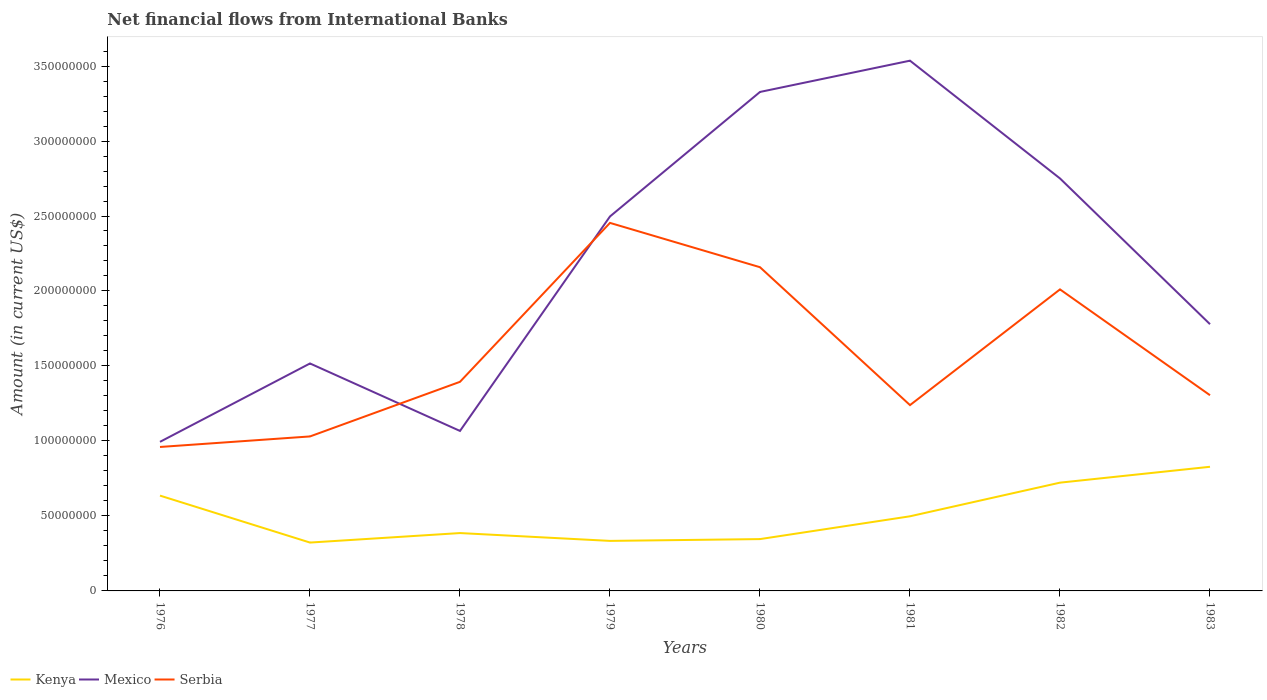Is the number of lines equal to the number of legend labels?
Offer a very short reply. Yes. Across all years, what is the maximum net financial aid flows in Mexico?
Make the answer very short. 9.94e+07. In which year was the net financial aid flows in Serbia maximum?
Keep it short and to the point. 1976. What is the total net financial aid flows in Kenya in the graph?
Provide a short and direct response. -1.11e+06. What is the difference between the highest and the second highest net financial aid flows in Serbia?
Provide a succinct answer. 1.49e+08. How many lines are there?
Your answer should be very brief. 3. How many years are there in the graph?
Ensure brevity in your answer.  8. Are the values on the major ticks of Y-axis written in scientific E-notation?
Your response must be concise. No. Does the graph contain grids?
Ensure brevity in your answer.  No. How many legend labels are there?
Your response must be concise. 3. How are the legend labels stacked?
Your response must be concise. Horizontal. What is the title of the graph?
Offer a terse response. Net financial flows from International Banks. Does "Colombia" appear as one of the legend labels in the graph?
Keep it short and to the point. No. What is the label or title of the X-axis?
Provide a succinct answer. Years. What is the label or title of the Y-axis?
Ensure brevity in your answer.  Amount (in current US$). What is the Amount (in current US$) of Kenya in 1976?
Your answer should be compact. 6.36e+07. What is the Amount (in current US$) of Mexico in 1976?
Offer a very short reply. 9.94e+07. What is the Amount (in current US$) in Serbia in 1976?
Offer a very short reply. 9.60e+07. What is the Amount (in current US$) in Kenya in 1977?
Keep it short and to the point. 3.22e+07. What is the Amount (in current US$) in Mexico in 1977?
Provide a short and direct response. 1.52e+08. What is the Amount (in current US$) in Serbia in 1977?
Your answer should be very brief. 1.03e+08. What is the Amount (in current US$) in Kenya in 1978?
Your answer should be compact. 3.86e+07. What is the Amount (in current US$) of Mexico in 1978?
Provide a succinct answer. 1.07e+08. What is the Amount (in current US$) of Serbia in 1978?
Offer a terse response. 1.39e+08. What is the Amount (in current US$) in Kenya in 1979?
Offer a terse response. 3.34e+07. What is the Amount (in current US$) of Mexico in 1979?
Keep it short and to the point. 2.50e+08. What is the Amount (in current US$) of Serbia in 1979?
Make the answer very short. 2.45e+08. What is the Amount (in current US$) of Kenya in 1980?
Your response must be concise. 3.46e+07. What is the Amount (in current US$) in Mexico in 1980?
Offer a very short reply. 3.33e+08. What is the Amount (in current US$) in Serbia in 1980?
Keep it short and to the point. 2.16e+08. What is the Amount (in current US$) of Kenya in 1981?
Provide a short and direct response. 4.98e+07. What is the Amount (in current US$) in Mexico in 1981?
Offer a very short reply. 3.54e+08. What is the Amount (in current US$) of Serbia in 1981?
Ensure brevity in your answer.  1.24e+08. What is the Amount (in current US$) in Kenya in 1982?
Your answer should be compact. 7.22e+07. What is the Amount (in current US$) of Mexico in 1982?
Your answer should be compact. 2.75e+08. What is the Amount (in current US$) of Serbia in 1982?
Your answer should be compact. 2.01e+08. What is the Amount (in current US$) in Kenya in 1983?
Offer a very short reply. 8.28e+07. What is the Amount (in current US$) in Mexico in 1983?
Keep it short and to the point. 1.78e+08. What is the Amount (in current US$) of Serbia in 1983?
Provide a succinct answer. 1.30e+08. Across all years, what is the maximum Amount (in current US$) of Kenya?
Provide a short and direct response. 8.28e+07. Across all years, what is the maximum Amount (in current US$) of Mexico?
Provide a succinct answer. 3.54e+08. Across all years, what is the maximum Amount (in current US$) of Serbia?
Give a very brief answer. 2.45e+08. Across all years, what is the minimum Amount (in current US$) of Kenya?
Your answer should be compact. 3.22e+07. Across all years, what is the minimum Amount (in current US$) in Mexico?
Your response must be concise. 9.94e+07. Across all years, what is the minimum Amount (in current US$) in Serbia?
Make the answer very short. 9.60e+07. What is the total Amount (in current US$) in Kenya in the graph?
Your answer should be compact. 4.07e+08. What is the total Amount (in current US$) in Mexico in the graph?
Ensure brevity in your answer.  1.75e+09. What is the total Amount (in current US$) in Serbia in the graph?
Give a very brief answer. 1.26e+09. What is the difference between the Amount (in current US$) in Kenya in 1976 and that in 1977?
Offer a very short reply. 3.13e+07. What is the difference between the Amount (in current US$) of Mexico in 1976 and that in 1977?
Your answer should be very brief. -5.23e+07. What is the difference between the Amount (in current US$) of Serbia in 1976 and that in 1977?
Your answer should be very brief. -7.02e+06. What is the difference between the Amount (in current US$) in Kenya in 1976 and that in 1978?
Give a very brief answer. 2.50e+07. What is the difference between the Amount (in current US$) in Mexico in 1976 and that in 1978?
Ensure brevity in your answer.  -7.27e+06. What is the difference between the Amount (in current US$) of Serbia in 1976 and that in 1978?
Your answer should be very brief. -4.34e+07. What is the difference between the Amount (in current US$) in Kenya in 1976 and that in 1979?
Your answer should be very brief. 3.02e+07. What is the difference between the Amount (in current US$) in Mexico in 1976 and that in 1979?
Offer a very short reply. -1.50e+08. What is the difference between the Amount (in current US$) in Serbia in 1976 and that in 1979?
Make the answer very short. -1.49e+08. What is the difference between the Amount (in current US$) of Kenya in 1976 and that in 1980?
Provide a short and direct response. 2.90e+07. What is the difference between the Amount (in current US$) in Mexico in 1976 and that in 1980?
Give a very brief answer. -2.33e+08. What is the difference between the Amount (in current US$) of Serbia in 1976 and that in 1980?
Provide a succinct answer. -1.20e+08. What is the difference between the Amount (in current US$) of Kenya in 1976 and that in 1981?
Your response must be concise. 1.38e+07. What is the difference between the Amount (in current US$) in Mexico in 1976 and that in 1981?
Offer a terse response. -2.54e+08. What is the difference between the Amount (in current US$) in Serbia in 1976 and that in 1981?
Provide a succinct answer. -2.79e+07. What is the difference between the Amount (in current US$) in Kenya in 1976 and that in 1982?
Provide a succinct answer. -8.65e+06. What is the difference between the Amount (in current US$) in Mexico in 1976 and that in 1982?
Give a very brief answer. -1.76e+08. What is the difference between the Amount (in current US$) of Serbia in 1976 and that in 1982?
Offer a very short reply. -1.05e+08. What is the difference between the Amount (in current US$) of Kenya in 1976 and that in 1983?
Provide a succinct answer. -1.92e+07. What is the difference between the Amount (in current US$) in Mexico in 1976 and that in 1983?
Ensure brevity in your answer.  -7.85e+07. What is the difference between the Amount (in current US$) of Serbia in 1976 and that in 1983?
Offer a terse response. -3.45e+07. What is the difference between the Amount (in current US$) of Kenya in 1977 and that in 1978?
Provide a succinct answer. -6.34e+06. What is the difference between the Amount (in current US$) of Mexico in 1977 and that in 1978?
Your response must be concise. 4.50e+07. What is the difference between the Amount (in current US$) in Serbia in 1977 and that in 1978?
Provide a succinct answer. -3.64e+07. What is the difference between the Amount (in current US$) of Kenya in 1977 and that in 1979?
Your response must be concise. -1.11e+06. What is the difference between the Amount (in current US$) of Mexico in 1977 and that in 1979?
Give a very brief answer. -9.80e+07. What is the difference between the Amount (in current US$) in Serbia in 1977 and that in 1979?
Your answer should be very brief. -1.42e+08. What is the difference between the Amount (in current US$) of Kenya in 1977 and that in 1980?
Provide a short and direct response. -2.32e+06. What is the difference between the Amount (in current US$) in Mexico in 1977 and that in 1980?
Make the answer very short. -1.81e+08. What is the difference between the Amount (in current US$) in Serbia in 1977 and that in 1980?
Ensure brevity in your answer.  -1.13e+08. What is the difference between the Amount (in current US$) in Kenya in 1977 and that in 1981?
Keep it short and to the point. -1.75e+07. What is the difference between the Amount (in current US$) of Mexico in 1977 and that in 1981?
Your response must be concise. -2.02e+08. What is the difference between the Amount (in current US$) in Serbia in 1977 and that in 1981?
Make the answer very short. -2.09e+07. What is the difference between the Amount (in current US$) in Kenya in 1977 and that in 1982?
Provide a short and direct response. -4.00e+07. What is the difference between the Amount (in current US$) in Mexico in 1977 and that in 1982?
Your response must be concise. -1.23e+08. What is the difference between the Amount (in current US$) in Serbia in 1977 and that in 1982?
Ensure brevity in your answer.  -9.80e+07. What is the difference between the Amount (in current US$) of Kenya in 1977 and that in 1983?
Give a very brief answer. -5.05e+07. What is the difference between the Amount (in current US$) of Mexico in 1977 and that in 1983?
Keep it short and to the point. -2.62e+07. What is the difference between the Amount (in current US$) in Serbia in 1977 and that in 1983?
Your answer should be compact. -2.75e+07. What is the difference between the Amount (in current US$) in Kenya in 1978 and that in 1979?
Your answer should be very brief. 5.22e+06. What is the difference between the Amount (in current US$) in Mexico in 1978 and that in 1979?
Keep it short and to the point. -1.43e+08. What is the difference between the Amount (in current US$) of Serbia in 1978 and that in 1979?
Offer a very short reply. -1.06e+08. What is the difference between the Amount (in current US$) of Kenya in 1978 and that in 1980?
Your answer should be very brief. 4.02e+06. What is the difference between the Amount (in current US$) in Mexico in 1978 and that in 1980?
Offer a terse response. -2.26e+08. What is the difference between the Amount (in current US$) in Serbia in 1978 and that in 1980?
Your answer should be very brief. -7.64e+07. What is the difference between the Amount (in current US$) of Kenya in 1978 and that in 1981?
Your answer should be very brief. -1.12e+07. What is the difference between the Amount (in current US$) of Mexico in 1978 and that in 1981?
Offer a very short reply. -2.47e+08. What is the difference between the Amount (in current US$) of Serbia in 1978 and that in 1981?
Make the answer very short. 1.55e+07. What is the difference between the Amount (in current US$) in Kenya in 1978 and that in 1982?
Give a very brief answer. -3.36e+07. What is the difference between the Amount (in current US$) of Mexico in 1978 and that in 1982?
Your answer should be very brief. -1.68e+08. What is the difference between the Amount (in current US$) of Serbia in 1978 and that in 1982?
Ensure brevity in your answer.  -6.16e+07. What is the difference between the Amount (in current US$) in Kenya in 1978 and that in 1983?
Your answer should be very brief. -4.42e+07. What is the difference between the Amount (in current US$) of Mexico in 1978 and that in 1983?
Ensure brevity in your answer.  -7.12e+07. What is the difference between the Amount (in current US$) in Serbia in 1978 and that in 1983?
Give a very brief answer. 8.94e+06. What is the difference between the Amount (in current US$) in Kenya in 1979 and that in 1980?
Keep it short and to the point. -1.20e+06. What is the difference between the Amount (in current US$) of Mexico in 1979 and that in 1980?
Offer a very short reply. -8.30e+07. What is the difference between the Amount (in current US$) of Serbia in 1979 and that in 1980?
Ensure brevity in your answer.  2.95e+07. What is the difference between the Amount (in current US$) of Kenya in 1979 and that in 1981?
Provide a succinct answer. -1.64e+07. What is the difference between the Amount (in current US$) of Mexico in 1979 and that in 1981?
Offer a very short reply. -1.04e+08. What is the difference between the Amount (in current US$) of Serbia in 1979 and that in 1981?
Provide a succinct answer. 1.22e+08. What is the difference between the Amount (in current US$) of Kenya in 1979 and that in 1982?
Your response must be concise. -3.88e+07. What is the difference between the Amount (in current US$) of Mexico in 1979 and that in 1982?
Give a very brief answer. -2.53e+07. What is the difference between the Amount (in current US$) in Serbia in 1979 and that in 1982?
Give a very brief answer. 4.43e+07. What is the difference between the Amount (in current US$) of Kenya in 1979 and that in 1983?
Make the answer very short. -4.94e+07. What is the difference between the Amount (in current US$) in Mexico in 1979 and that in 1983?
Provide a succinct answer. 7.18e+07. What is the difference between the Amount (in current US$) in Serbia in 1979 and that in 1983?
Give a very brief answer. 1.15e+08. What is the difference between the Amount (in current US$) of Kenya in 1980 and that in 1981?
Offer a terse response. -1.52e+07. What is the difference between the Amount (in current US$) of Mexico in 1980 and that in 1981?
Provide a succinct answer. -2.09e+07. What is the difference between the Amount (in current US$) in Serbia in 1980 and that in 1981?
Provide a short and direct response. 9.20e+07. What is the difference between the Amount (in current US$) of Kenya in 1980 and that in 1982?
Provide a succinct answer. -3.76e+07. What is the difference between the Amount (in current US$) of Mexico in 1980 and that in 1982?
Provide a succinct answer. 5.77e+07. What is the difference between the Amount (in current US$) of Serbia in 1980 and that in 1982?
Make the answer very short. 1.48e+07. What is the difference between the Amount (in current US$) in Kenya in 1980 and that in 1983?
Keep it short and to the point. -4.82e+07. What is the difference between the Amount (in current US$) in Mexico in 1980 and that in 1983?
Give a very brief answer. 1.55e+08. What is the difference between the Amount (in current US$) in Serbia in 1980 and that in 1983?
Give a very brief answer. 8.54e+07. What is the difference between the Amount (in current US$) of Kenya in 1981 and that in 1982?
Keep it short and to the point. -2.24e+07. What is the difference between the Amount (in current US$) in Mexico in 1981 and that in 1982?
Provide a short and direct response. 7.85e+07. What is the difference between the Amount (in current US$) of Serbia in 1981 and that in 1982?
Ensure brevity in your answer.  -7.72e+07. What is the difference between the Amount (in current US$) in Kenya in 1981 and that in 1983?
Make the answer very short. -3.30e+07. What is the difference between the Amount (in current US$) of Mexico in 1981 and that in 1983?
Your response must be concise. 1.76e+08. What is the difference between the Amount (in current US$) in Serbia in 1981 and that in 1983?
Offer a terse response. -6.60e+06. What is the difference between the Amount (in current US$) in Kenya in 1982 and that in 1983?
Ensure brevity in your answer.  -1.06e+07. What is the difference between the Amount (in current US$) in Mexico in 1982 and that in 1983?
Your response must be concise. 9.72e+07. What is the difference between the Amount (in current US$) of Serbia in 1982 and that in 1983?
Provide a short and direct response. 7.06e+07. What is the difference between the Amount (in current US$) in Kenya in 1976 and the Amount (in current US$) in Mexico in 1977?
Offer a very short reply. -8.81e+07. What is the difference between the Amount (in current US$) of Kenya in 1976 and the Amount (in current US$) of Serbia in 1977?
Your answer should be very brief. -3.95e+07. What is the difference between the Amount (in current US$) in Mexico in 1976 and the Amount (in current US$) in Serbia in 1977?
Offer a terse response. -3.61e+06. What is the difference between the Amount (in current US$) in Kenya in 1976 and the Amount (in current US$) in Mexico in 1978?
Offer a very short reply. -4.31e+07. What is the difference between the Amount (in current US$) of Kenya in 1976 and the Amount (in current US$) of Serbia in 1978?
Offer a very short reply. -7.59e+07. What is the difference between the Amount (in current US$) of Mexico in 1976 and the Amount (in current US$) of Serbia in 1978?
Offer a very short reply. -4.00e+07. What is the difference between the Amount (in current US$) of Kenya in 1976 and the Amount (in current US$) of Mexico in 1979?
Offer a very short reply. -1.86e+08. What is the difference between the Amount (in current US$) of Kenya in 1976 and the Amount (in current US$) of Serbia in 1979?
Keep it short and to the point. -1.82e+08. What is the difference between the Amount (in current US$) in Mexico in 1976 and the Amount (in current US$) in Serbia in 1979?
Offer a terse response. -1.46e+08. What is the difference between the Amount (in current US$) of Kenya in 1976 and the Amount (in current US$) of Mexico in 1980?
Your response must be concise. -2.69e+08. What is the difference between the Amount (in current US$) in Kenya in 1976 and the Amount (in current US$) in Serbia in 1980?
Your answer should be very brief. -1.52e+08. What is the difference between the Amount (in current US$) of Mexico in 1976 and the Amount (in current US$) of Serbia in 1980?
Your response must be concise. -1.16e+08. What is the difference between the Amount (in current US$) of Kenya in 1976 and the Amount (in current US$) of Mexico in 1981?
Your answer should be compact. -2.90e+08. What is the difference between the Amount (in current US$) of Kenya in 1976 and the Amount (in current US$) of Serbia in 1981?
Your answer should be very brief. -6.03e+07. What is the difference between the Amount (in current US$) in Mexico in 1976 and the Amount (in current US$) in Serbia in 1981?
Provide a succinct answer. -2.45e+07. What is the difference between the Amount (in current US$) in Kenya in 1976 and the Amount (in current US$) in Mexico in 1982?
Provide a succinct answer. -2.11e+08. What is the difference between the Amount (in current US$) in Kenya in 1976 and the Amount (in current US$) in Serbia in 1982?
Offer a terse response. -1.38e+08. What is the difference between the Amount (in current US$) of Mexico in 1976 and the Amount (in current US$) of Serbia in 1982?
Your answer should be compact. -1.02e+08. What is the difference between the Amount (in current US$) in Kenya in 1976 and the Amount (in current US$) in Mexico in 1983?
Offer a terse response. -1.14e+08. What is the difference between the Amount (in current US$) in Kenya in 1976 and the Amount (in current US$) in Serbia in 1983?
Give a very brief answer. -6.69e+07. What is the difference between the Amount (in current US$) of Mexico in 1976 and the Amount (in current US$) of Serbia in 1983?
Provide a short and direct response. -3.11e+07. What is the difference between the Amount (in current US$) in Kenya in 1977 and the Amount (in current US$) in Mexico in 1978?
Ensure brevity in your answer.  -7.44e+07. What is the difference between the Amount (in current US$) in Kenya in 1977 and the Amount (in current US$) in Serbia in 1978?
Your response must be concise. -1.07e+08. What is the difference between the Amount (in current US$) in Mexico in 1977 and the Amount (in current US$) in Serbia in 1978?
Give a very brief answer. 1.22e+07. What is the difference between the Amount (in current US$) in Kenya in 1977 and the Amount (in current US$) in Mexico in 1979?
Offer a terse response. -2.17e+08. What is the difference between the Amount (in current US$) of Kenya in 1977 and the Amount (in current US$) of Serbia in 1979?
Make the answer very short. -2.13e+08. What is the difference between the Amount (in current US$) of Mexico in 1977 and the Amount (in current US$) of Serbia in 1979?
Your answer should be compact. -9.37e+07. What is the difference between the Amount (in current US$) in Kenya in 1977 and the Amount (in current US$) in Mexico in 1980?
Provide a short and direct response. -3.00e+08. What is the difference between the Amount (in current US$) of Kenya in 1977 and the Amount (in current US$) of Serbia in 1980?
Your answer should be very brief. -1.84e+08. What is the difference between the Amount (in current US$) of Mexico in 1977 and the Amount (in current US$) of Serbia in 1980?
Ensure brevity in your answer.  -6.42e+07. What is the difference between the Amount (in current US$) of Kenya in 1977 and the Amount (in current US$) of Mexico in 1981?
Your answer should be very brief. -3.21e+08. What is the difference between the Amount (in current US$) of Kenya in 1977 and the Amount (in current US$) of Serbia in 1981?
Provide a succinct answer. -9.17e+07. What is the difference between the Amount (in current US$) in Mexico in 1977 and the Amount (in current US$) in Serbia in 1981?
Offer a very short reply. 2.78e+07. What is the difference between the Amount (in current US$) of Kenya in 1977 and the Amount (in current US$) of Mexico in 1982?
Give a very brief answer. -2.43e+08. What is the difference between the Amount (in current US$) of Kenya in 1977 and the Amount (in current US$) of Serbia in 1982?
Offer a terse response. -1.69e+08. What is the difference between the Amount (in current US$) in Mexico in 1977 and the Amount (in current US$) in Serbia in 1982?
Give a very brief answer. -4.94e+07. What is the difference between the Amount (in current US$) of Kenya in 1977 and the Amount (in current US$) of Mexico in 1983?
Keep it short and to the point. -1.46e+08. What is the difference between the Amount (in current US$) of Kenya in 1977 and the Amount (in current US$) of Serbia in 1983?
Your answer should be compact. -9.82e+07. What is the difference between the Amount (in current US$) of Mexico in 1977 and the Amount (in current US$) of Serbia in 1983?
Provide a succinct answer. 2.12e+07. What is the difference between the Amount (in current US$) in Kenya in 1978 and the Amount (in current US$) in Mexico in 1979?
Provide a short and direct response. -2.11e+08. What is the difference between the Amount (in current US$) of Kenya in 1978 and the Amount (in current US$) of Serbia in 1979?
Give a very brief answer. -2.07e+08. What is the difference between the Amount (in current US$) in Mexico in 1978 and the Amount (in current US$) in Serbia in 1979?
Your response must be concise. -1.39e+08. What is the difference between the Amount (in current US$) in Kenya in 1978 and the Amount (in current US$) in Mexico in 1980?
Your answer should be compact. -2.94e+08. What is the difference between the Amount (in current US$) in Kenya in 1978 and the Amount (in current US$) in Serbia in 1980?
Offer a very short reply. -1.77e+08. What is the difference between the Amount (in current US$) of Mexico in 1978 and the Amount (in current US$) of Serbia in 1980?
Your answer should be compact. -1.09e+08. What is the difference between the Amount (in current US$) of Kenya in 1978 and the Amount (in current US$) of Mexico in 1981?
Ensure brevity in your answer.  -3.15e+08. What is the difference between the Amount (in current US$) in Kenya in 1978 and the Amount (in current US$) in Serbia in 1981?
Ensure brevity in your answer.  -8.53e+07. What is the difference between the Amount (in current US$) of Mexico in 1978 and the Amount (in current US$) of Serbia in 1981?
Ensure brevity in your answer.  -1.72e+07. What is the difference between the Amount (in current US$) in Kenya in 1978 and the Amount (in current US$) in Mexico in 1982?
Offer a very short reply. -2.36e+08. What is the difference between the Amount (in current US$) of Kenya in 1978 and the Amount (in current US$) of Serbia in 1982?
Make the answer very short. -1.62e+08. What is the difference between the Amount (in current US$) in Mexico in 1978 and the Amount (in current US$) in Serbia in 1982?
Your response must be concise. -9.44e+07. What is the difference between the Amount (in current US$) of Kenya in 1978 and the Amount (in current US$) of Mexico in 1983?
Offer a very short reply. -1.39e+08. What is the difference between the Amount (in current US$) in Kenya in 1978 and the Amount (in current US$) in Serbia in 1983?
Your answer should be compact. -9.19e+07. What is the difference between the Amount (in current US$) of Mexico in 1978 and the Amount (in current US$) of Serbia in 1983?
Give a very brief answer. -2.38e+07. What is the difference between the Amount (in current US$) in Kenya in 1979 and the Amount (in current US$) in Mexico in 1980?
Offer a very short reply. -2.99e+08. What is the difference between the Amount (in current US$) in Kenya in 1979 and the Amount (in current US$) in Serbia in 1980?
Ensure brevity in your answer.  -1.82e+08. What is the difference between the Amount (in current US$) of Mexico in 1979 and the Amount (in current US$) of Serbia in 1980?
Offer a terse response. 3.39e+07. What is the difference between the Amount (in current US$) in Kenya in 1979 and the Amount (in current US$) in Mexico in 1981?
Your answer should be very brief. -3.20e+08. What is the difference between the Amount (in current US$) in Kenya in 1979 and the Amount (in current US$) in Serbia in 1981?
Provide a short and direct response. -9.05e+07. What is the difference between the Amount (in current US$) in Mexico in 1979 and the Amount (in current US$) in Serbia in 1981?
Your answer should be compact. 1.26e+08. What is the difference between the Amount (in current US$) of Kenya in 1979 and the Amount (in current US$) of Mexico in 1982?
Provide a short and direct response. -2.42e+08. What is the difference between the Amount (in current US$) of Kenya in 1979 and the Amount (in current US$) of Serbia in 1982?
Your answer should be compact. -1.68e+08. What is the difference between the Amount (in current US$) of Mexico in 1979 and the Amount (in current US$) of Serbia in 1982?
Your response must be concise. 4.86e+07. What is the difference between the Amount (in current US$) in Kenya in 1979 and the Amount (in current US$) in Mexico in 1983?
Keep it short and to the point. -1.45e+08. What is the difference between the Amount (in current US$) in Kenya in 1979 and the Amount (in current US$) in Serbia in 1983?
Offer a terse response. -9.71e+07. What is the difference between the Amount (in current US$) in Mexico in 1979 and the Amount (in current US$) in Serbia in 1983?
Ensure brevity in your answer.  1.19e+08. What is the difference between the Amount (in current US$) in Kenya in 1980 and the Amount (in current US$) in Mexico in 1981?
Provide a short and direct response. -3.19e+08. What is the difference between the Amount (in current US$) in Kenya in 1980 and the Amount (in current US$) in Serbia in 1981?
Give a very brief answer. -8.93e+07. What is the difference between the Amount (in current US$) of Mexico in 1980 and the Amount (in current US$) of Serbia in 1981?
Provide a succinct answer. 2.09e+08. What is the difference between the Amount (in current US$) of Kenya in 1980 and the Amount (in current US$) of Mexico in 1982?
Offer a terse response. -2.40e+08. What is the difference between the Amount (in current US$) of Kenya in 1980 and the Amount (in current US$) of Serbia in 1982?
Offer a terse response. -1.67e+08. What is the difference between the Amount (in current US$) of Mexico in 1980 and the Amount (in current US$) of Serbia in 1982?
Your answer should be very brief. 1.32e+08. What is the difference between the Amount (in current US$) in Kenya in 1980 and the Amount (in current US$) in Mexico in 1983?
Give a very brief answer. -1.43e+08. What is the difference between the Amount (in current US$) in Kenya in 1980 and the Amount (in current US$) in Serbia in 1983?
Your answer should be compact. -9.59e+07. What is the difference between the Amount (in current US$) of Mexico in 1980 and the Amount (in current US$) of Serbia in 1983?
Your answer should be compact. 2.02e+08. What is the difference between the Amount (in current US$) in Kenya in 1981 and the Amount (in current US$) in Mexico in 1982?
Offer a very short reply. -2.25e+08. What is the difference between the Amount (in current US$) of Kenya in 1981 and the Amount (in current US$) of Serbia in 1982?
Give a very brief answer. -1.51e+08. What is the difference between the Amount (in current US$) in Mexico in 1981 and the Amount (in current US$) in Serbia in 1982?
Ensure brevity in your answer.  1.53e+08. What is the difference between the Amount (in current US$) in Kenya in 1981 and the Amount (in current US$) in Mexico in 1983?
Your response must be concise. -1.28e+08. What is the difference between the Amount (in current US$) of Kenya in 1981 and the Amount (in current US$) of Serbia in 1983?
Make the answer very short. -8.07e+07. What is the difference between the Amount (in current US$) of Mexico in 1981 and the Amount (in current US$) of Serbia in 1983?
Provide a succinct answer. 2.23e+08. What is the difference between the Amount (in current US$) in Kenya in 1982 and the Amount (in current US$) in Mexico in 1983?
Provide a succinct answer. -1.06e+08. What is the difference between the Amount (in current US$) of Kenya in 1982 and the Amount (in current US$) of Serbia in 1983?
Ensure brevity in your answer.  -5.83e+07. What is the difference between the Amount (in current US$) of Mexico in 1982 and the Amount (in current US$) of Serbia in 1983?
Your answer should be very brief. 1.45e+08. What is the average Amount (in current US$) of Kenya per year?
Ensure brevity in your answer.  5.09e+07. What is the average Amount (in current US$) of Mexico per year?
Offer a terse response. 2.18e+08. What is the average Amount (in current US$) in Serbia per year?
Your answer should be compact. 1.57e+08. In the year 1976, what is the difference between the Amount (in current US$) in Kenya and Amount (in current US$) in Mexico?
Your answer should be very brief. -3.59e+07. In the year 1976, what is the difference between the Amount (in current US$) in Kenya and Amount (in current US$) in Serbia?
Make the answer very short. -3.24e+07. In the year 1976, what is the difference between the Amount (in current US$) of Mexico and Amount (in current US$) of Serbia?
Your answer should be compact. 3.42e+06. In the year 1977, what is the difference between the Amount (in current US$) in Kenya and Amount (in current US$) in Mexico?
Your answer should be compact. -1.19e+08. In the year 1977, what is the difference between the Amount (in current US$) of Kenya and Amount (in current US$) of Serbia?
Offer a terse response. -7.08e+07. In the year 1977, what is the difference between the Amount (in current US$) in Mexico and Amount (in current US$) in Serbia?
Give a very brief answer. 4.87e+07. In the year 1978, what is the difference between the Amount (in current US$) of Kenya and Amount (in current US$) of Mexico?
Your response must be concise. -6.81e+07. In the year 1978, what is the difference between the Amount (in current US$) in Kenya and Amount (in current US$) in Serbia?
Your answer should be very brief. -1.01e+08. In the year 1978, what is the difference between the Amount (in current US$) of Mexico and Amount (in current US$) of Serbia?
Your answer should be compact. -3.28e+07. In the year 1979, what is the difference between the Amount (in current US$) in Kenya and Amount (in current US$) in Mexico?
Keep it short and to the point. -2.16e+08. In the year 1979, what is the difference between the Amount (in current US$) in Kenya and Amount (in current US$) in Serbia?
Make the answer very short. -2.12e+08. In the year 1979, what is the difference between the Amount (in current US$) of Mexico and Amount (in current US$) of Serbia?
Your answer should be very brief. 4.30e+06. In the year 1980, what is the difference between the Amount (in current US$) of Kenya and Amount (in current US$) of Mexico?
Give a very brief answer. -2.98e+08. In the year 1980, what is the difference between the Amount (in current US$) in Kenya and Amount (in current US$) in Serbia?
Offer a very short reply. -1.81e+08. In the year 1980, what is the difference between the Amount (in current US$) of Mexico and Amount (in current US$) of Serbia?
Provide a succinct answer. 1.17e+08. In the year 1981, what is the difference between the Amount (in current US$) in Kenya and Amount (in current US$) in Mexico?
Provide a succinct answer. -3.04e+08. In the year 1981, what is the difference between the Amount (in current US$) of Kenya and Amount (in current US$) of Serbia?
Your answer should be compact. -7.41e+07. In the year 1981, what is the difference between the Amount (in current US$) in Mexico and Amount (in current US$) in Serbia?
Your answer should be very brief. 2.30e+08. In the year 1982, what is the difference between the Amount (in current US$) of Kenya and Amount (in current US$) of Mexico?
Ensure brevity in your answer.  -2.03e+08. In the year 1982, what is the difference between the Amount (in current US$) of Kenya and Amount (in current US$) of Serbia?
Your answer should be very brief. -1.29e+08. In the year 1982, what is the difference between the Amount (in current US$) of Mexico and Amount (in current US$) of Serbia?
Your answer should be compact. 7.40e+07. In the year 1983, what is the difference between the Amount (in current US$) in Kenya and Amount (in current US$) in Mexico?
Keep it short and to the point. -9.51e+07. In the year 1983, what is the difference between the Amount (in current US$) of Kenya and Amount (in current US$) of Serbia?
Keep it short and to the point. -4.77e+07. In the year 1983, what is the difference between the Amount (in current US$) in Mexico and Amount (in current US$) in Serbia?
Your answer should be very brief. 4.74e+07. What is the ratio of the Amount (in current US$) in Kenya in 1976 to that in 1977?
Give a very brief answer. 1.97. What is the ratio of the Amount (in current US$) in Mexico in 1976 to that in 1977?
Keep it short and to the point. 0.66. What is the ratio of the Amount (in current US$) of Serbia in 1976 to that in 1977?
Keep it short and to the point. 0.93. What is the ratio of the Amount (in current US$) in Kenya in 1976 to that in 1978?
Your answer should be compact. 1.65. What is the ratio of the Amount (in current US$) of Mexico in 1976 to that in 1978?
Offer a terse response. 0.93. What is the ratio of the Amount (in current US$) in Serbia in 1976 to that in 1978?
Keep it short and to the point. 0.69. What is the ratio of the Amount (in current US$) in Kenya in 1976 to that in 1979?
Your response must be concise. 1.91. What is the ratio of the Amount (in current US$) of Mexico in 1976 to that in 1979?
Make the answer very short. 0.4. What is the ratio of the Amount (in current US$) in Serbia in 1976 to that in 1979?
Keep it short and to the point. 0.39. What is the ratio of the Amount (in current US$) of Kenya in 1976 to that in 1980?
Give a very brief answer. 1.84. What is the ratio of the Amount (in current US$) in Mexico in 1976 to that in 1980?
Offer a terse response. 0.3. What is the ratio of the Amount (in current US$) in Serbia in 1976 to that in 1980?
Your answer should be very brief. 0.44. What is the ratio of the Amount (in current US$) of Kenya in 1976 to that in 1981?
Your response must be concise. 1.28. What is the ratio of the Amount (in current US$) in Mexico in 1976 to that in 1981?
Your response must be concise. 0.28. What is the ratio of the Amount (in current US$) in Serbia in 1976 to that in 1981?
Offer a very short reply. 0.77. What is the ratio of the Amount (in current US$) in Kenya in 1976 to that in 1982?
Your answer should be very brief. 0.88. What is the ratio of the Amount (in current US$) of Mexico in 1976 to that in 1982?
Give a very brief answer. 0.36. What is the ratio of the Amount (in current US$) in Serbia in 1976 to that in 1982?
Offer a terse response. 0.48. What is the ratio of the Amount (in current US$) of Kenya in 1976 to that in 1983?
Your answer should be very brief. 0.77. What is the ratio of the Amount (in current US$) in Mexico in 1976 to that in 1983?
Provide a succinct answer. 0.56. What is the ratio of the Amount (in current US$) in Serbia in 1976 to that in 1983?
Your answer should be compact. 0.74. What is the ratio of the Amount (in current US$) in Kenya in 1977 to that in 1978?
Keep it short and to the point. 0.84. What is the ratio of the Amount (in current US$) in Mexico in 1977 to that in 1978?
Keep it short and to the point. 1.42. What is the ratio of the Amount (in current US$) in Serbia in 1977 to that in 1978?
Offer a very short reply. 0.74. What is the ratio of the Amount (in current US$) of Kenya in 1977 to that in 1979?
Make the answer very short. 0.97. What is the ratio of the Amount (in current US$) of Mexico in 1977 to that in 1979?
Your answer should be compact. 0.61. What is the ratio of the Amount (in current US$) of Serbia in 1977 to that in 1979?
Give a very brief answer. 0.42. What is the ratio of the Amount (in current US$) in Kenya in 1977 to that in 1980?
Your response must be concise. 0.93. What is the ratio of the Amount (in current US$) in Mexico in 1977 to that in 1980?
Ensure brevity in your answer.  0.46. What is the ratio of the Amount (in current US$) in Serbia in 1977 to that in 1980?
Ensure brevity in your answer.  0.48. What is the ratio of the Amount (in current US$) in Kenya in 1977 to that in 1981?
Your response must be concise. 0.65. What is the ratio of the Amount (in current US$) of Mexico in 1977 to that in 1981?
Your response must be concise. 0.43. What is the ratio of the Amount (in current US$) in Serbia in 1977 to that in 1981?
Your answer should be compact. 0.83. What is the ratio of the Amount (in current US$) of Kenya in 1977 to that in 1982?
Your answer should be very brief. 0.45. What is the ratio of the Amount (in current US$) of Mexico in 1977 to that in 1982?
Your answer should be very brief. 0.55. What is the ratio of the Amount (in current US$) in Serbia in 1977 to that in 1982?
Your answer should be compact. 0.51. What is the ratio of the Amount (in current US$) in Kenya in 1977 to that in 1983?
Keep it short and to the point. 0.39. What is the ratio of the Amount (in current US$) of Mexico in 1977 to that in 1983?
Provide a short and direct response. 0.85. What is the ratio of the Amount (in current US$) in Serbia in 1977 to that in 1983?
Your answer should be very brief. 0.79. What is the ratio of the Amount (in current US$) of Kenya in 1978 to that in 1979?
Offer a very short reply. 1.16. What is the ratio of the Amount (in current US$) in Mexico in 1978 to that in 1979?
Give a very brief answer. 0.43. What is the ratio of the Amount (in current US$) in Serbia in 1978 to that in 1979?
Provide a succinct answer. 0.57. What is the ratio of the Amount (in current US$) of Kenya in 1978 to that in 1980?
Give a very brief answer. 1.12. What is the ratio of the Amount (in current US$) in Mexico in 1978 to that in 1980?
Provide a succinct answer. 0.32. What is the ratio of the Amount (in current US$) of Serbia in 1978 to that in 1980?
Your response must be concise. 0.65. What is the ratio of the Amount (in current US$) in Kenya in 1978 to that in 1981?
Your answer should be very brief. 0.78. What is the ratio of the Amount (in current US$) in Mexico in 1978 to that in 1981?
Your response must be concise. 0.3. What is the ratio of the Amount (in current US$) in Serbia in 1978 to that in 1981?
Your answer should be compact. 1.13. What is the ratio of the Amount (in current US$) of Kenya in 1978 to that in 1982?
Ensure brevity in your answer.  0.53. What is the ratio of the Amount (in current US$) in Mexico in 1978 to that in 1982?
Your response must be concise. 0.39. What is the ratio of the Amount (in current US$) of Serbia in 1978 to that in 1982?
Make the answer very short. 0.69. What is the ratio of the Amount (in current US$) in Kenya in 1978 to that in 1983?
Ensure brevity in your answer.  0.47. What is the ratio of the Amount (in current US$) of Mexico in 1978 to that in 1983?
Ensure brevity in your answer.  0.6. What is the ratio of the Amount (in current US$) of Serbia in 1978 to that in 1983?
Your answer should be compact. 1.07. What is the ratio of the Amount (in current US$) in Kenya in 1979 to that in 1980?
Offer a very short reply. 0.97. What is the ratio of the Amount (in current US$) of Mexico in 1979 to that in 1980?
Offer a very short reply. 0.75. What is the ratio of the Amount (in current US$) in Serbia in 1979 to that in 1980?
Provide a succinct answer. 1.14. What is the ratio of the Amount (in current US$) of Kenya in 1979 to that in 1981?
Offer a very short reply. 0.67. What is the ratio of the Amount (in current US$) of Mexico in 1979 to that in 1981?
Your response must be concise. 0.71. What is the ratio of the Amount (in current US$) in Serbia in 1979 to that in 1981?
Make the answer very short. 1.98. What is the ratio of the Amount (in current US$) in Kenya in 1979 to that in 1982?
Ensure brevity in your answer.  0.46. What is the ratio of the Amount (in current US$) of Mexico in 1979 to that in 1982?
Give a very brief answer. 0.91. What is the ratio of the Amount (in current US$) in Serbia in 1979 to that in 1982?
Your response must be concise. 1.22. What is the ratio of the Amount (in current US$) of Kenya in 1979 to that in 1983?
Provide a succinct answer. 0.4. What is the ratio of the Amount (in current US$) in Mexico in 1979 to that in 1983?
Provide a succinct answer. 1.4. What is the ratio of the Amount (in current US$) of Serbia in 1979 to that in 1983?
Offer a very short reply. 1.88. What is the ratio of the Amount (in current US$) of Kenya in 1980 to that in 1981?
Your response must be concise. 0.69. What is the ratio of the Amount (in current US$) of Mexico in 1980 to that in 1981?
Your answer should be compact. 0.94. What is the ratio of the Amount (in current US$) of Serbia in 1980 to that in 1981?
Your response must be concise. 1.74. What is the ratio of the Amount (in current US$) of Kenya in 1980 to that in 1982?
Provide a short and direct response. 0.48. What is the ratio of the Amount (in current US$) of Mexico in 1980 to that in 1982?
Offer a very short reply. 1.21. What is the ratio of the Amount (in current US$) of Serbia in 1980 to that in 1982?
Your answer should be very brief. 1.07. What is the ratio of the Amount (in current US$) in Kenya in 1980 to that in 1983?
Offer a terse response. 0.42. What is the ratio of the Amount (in current US$) of Mexico in 1980 to that in 1983?
Provide a succinct answer. 1.87. What is the ratio of the Amount (in current US$) in Serbia in 1980 to that in 1983?
Keep it short and to the point. 1.65. What is the ratio of the Amount (in current US$) in Kenya in 1981 to that in 1982?
Offer a terse response. 0.69. What is the ratio of the Amount (in current US$) in Mexico in 1981 to that in 1982?
Give a very brief answer. 1.29. What is the ratio of the Amount (in current US$) in Serbia in 1981 to that in 1982?
Ensure brevity in your answer.  0.62. What is the ratio of the Amount (in current US$) in Kenya in 1981 to that in 1983?
Keep it short and to the point. 0.6. What is the ratio of the Amount (in current US$) in Mexico in 1981 to that in 1983?
Provide a short and direct response. 1.99. What is the ratio of the Amount (in current US$) in Serbia in 1981 to that in 1983?
Provide a short and direct response. 0.95. What is the ratio of the Amount (in current US$) of Kenya in 1982 to that in 1983?
Offer a very short reply. 0.87. What is the ratio of the Amount (in current US$) of Mexico in 1982 to that in 1983?
Provide a short and direct response. 1.55. What is the ratio of the Amount (in current US$) of Serbia in 1982 to that in 1983?
Provide a succinct answer. 1.54. What is the difference between the highest and the second highest Amount (in current US$) of Kenya?
Offer a very short reply. 1.06e+07. What is the difference between the highest and the second highest Amount (in current US$) in Mexico?
Ensure brevity in your answer.  2.09e+07. What is the difference between the highest and the second highest Amount (in current US$) in Serbia?
Keep it short and to the point. 2.95e+07. What is the difference between the highest and the lowest Amount (in current US$) of Kenya?
Make the answer very short. 5.05e+07. What is the difference between the highest and the lowest Amount (in current US$) of Mexico?
Your response must be concise. 2.54e+08. What is the difference between the highest and the lowest Amount (in current US$) in Serbia?
Your response must be concise. 1.49e+08. 